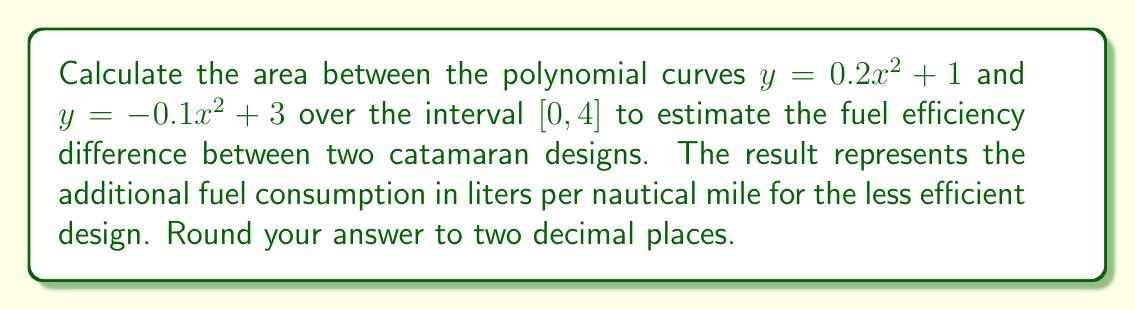Could you help me with this problem? To find the area between two polynomial curves, we follow these steps:

1) Identify the upper and lower curves:
   Upper curve: $y = -0.1x^2 + 3$
   Lower curve: $y = 0.2x^2 + 1$

2) Find the difference between the curves:
   $f(x) = (-0.1x^2 + 3) - (0.2x^2 + 1) = -0.3x^2 + 2$

3) Set up the definite integral:
   $$A = \int_0^4 f(x) dx = \int_0^4 (-0.3x^2 + 2) dx$$

4) Integrate:
   $$A = \left[-0.1x^3 + 2x\right]_0^4$$

5) Evaluate the integral:
   $$A = (-0.1(4^3) + 2(4)) - (-0.1(0^3) + 2(0))$$
   $$A = (-6.4 + 8) - (0) = 1.6$$

6) Round to two decimal places:
   $A \approx 1.60$

The area between the curves represents the additional fuel consumption in liters per nautical mile for the less efficient catamaran design.
Answer: 1.60 L/nm 